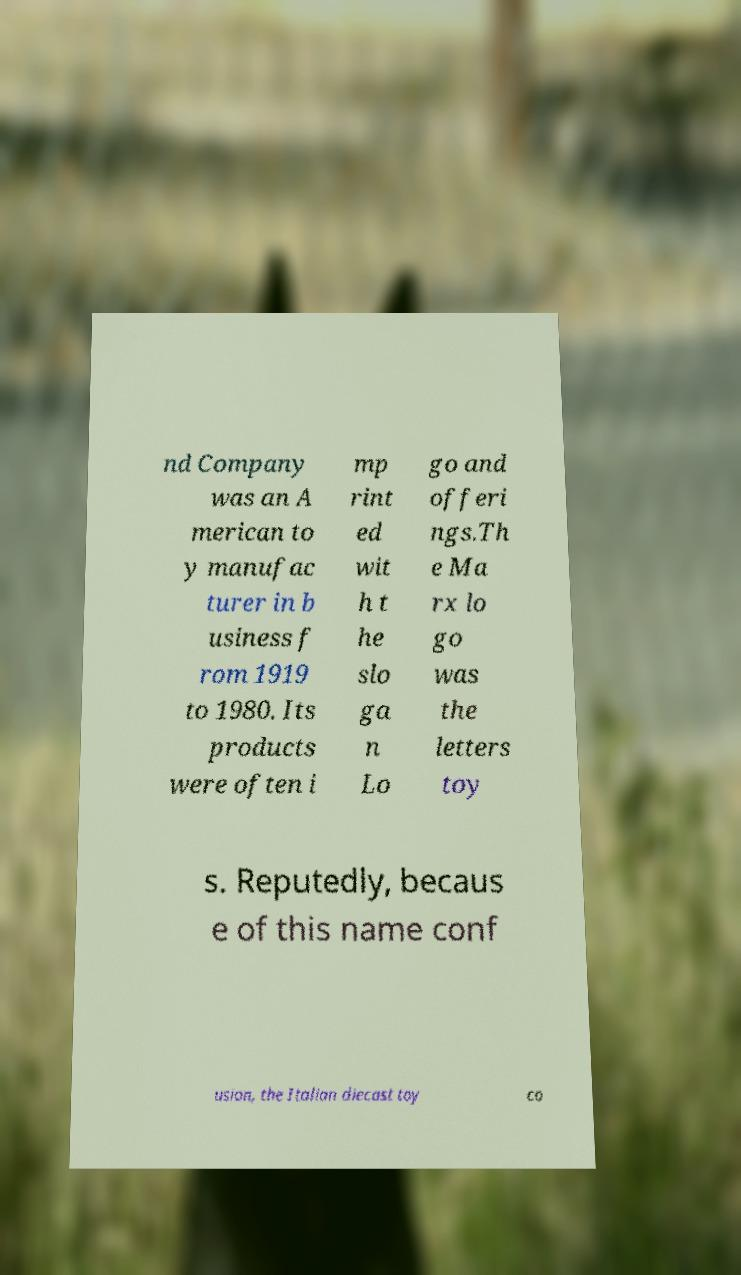For documentation purposes, I need the text within this image transcribed. Could you provide that? nd Company was an A merican to y manufac turer in b usiness f rom 1919 to 1980. Its products were often i mp rint ed wit h t he slo ga n Lo go and offeri ngs.Th e Ma rx lo go was the letters toy s. Reputedly, becaus e of this name conf usion, the Italian diecast toy co 